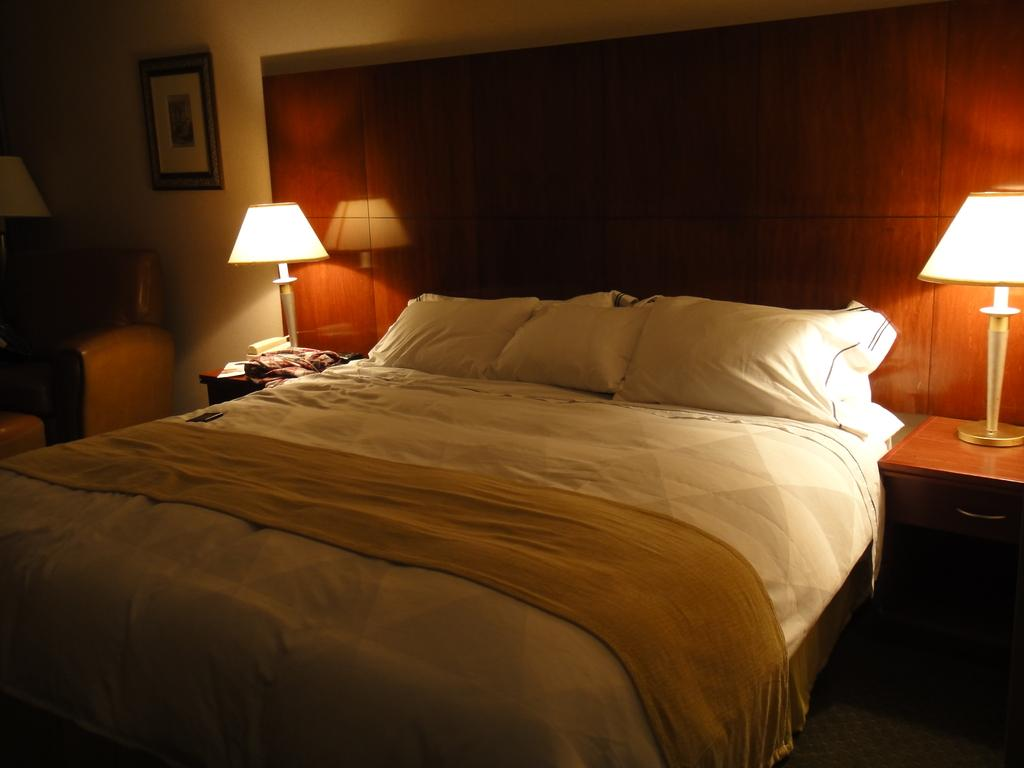What piece of furniture is present in the image? There is a bed in the image. How many pillows are on the bed? There are three pillows on the bed. What objects can be seen on the table? There are two lamps on the table. What is hanging on the wall? There is a photo frame on the wall. How many hands are visible in the image? There are no hands visible in the image. What type of crowd can be seen gathering around the bed? There is no crowd present in the image; it only shows a bed, pillows, lamps, and a photo frame. 